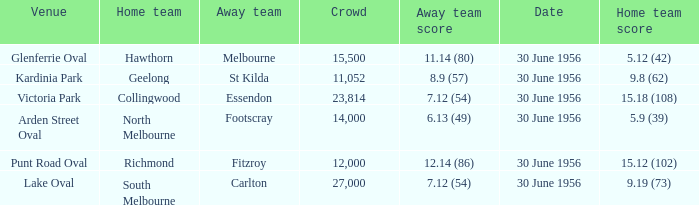What is the home team score when the away team is St Kilda? 9.8 (62). 